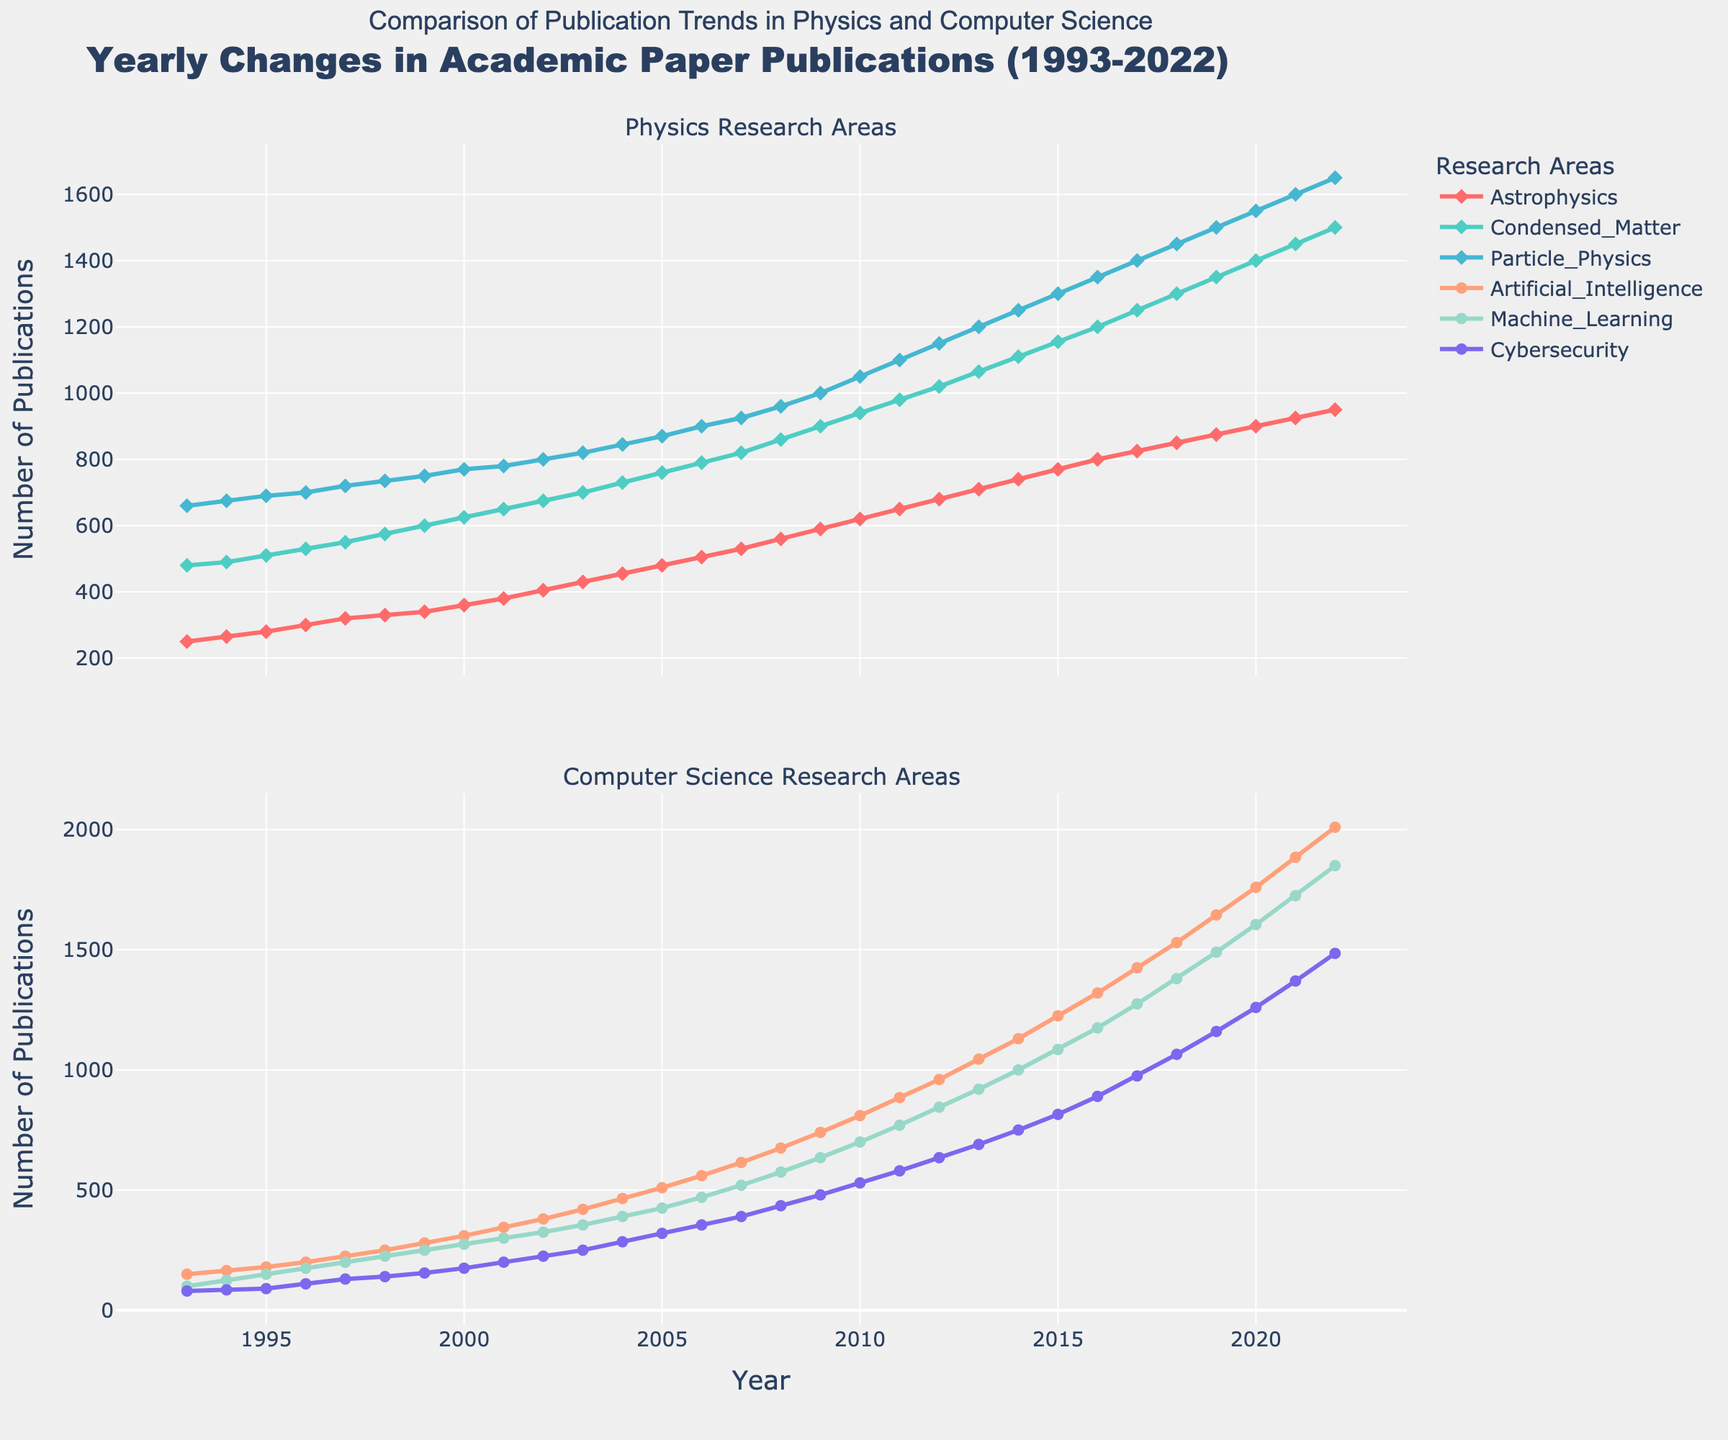What is the title of the plot? The title is located at the top of the figure and provides a summary of what the plot represents. It reads "Yearly Changes in Academic Paper Publications (1993-2022)".
Answer: Yearly Changes in Academic Paper Publications (1993-2022) Which research area in Computer Science had the highest number of publications in 2022? Looking at the bottom subplot for Computer Science research areas in 2022, the line representing Artificial Intelligence sits the highest on the vertical axis.
Answer: Artificial Intelligence What is the overall trend in the number of publications in the Condensed Matter subfield of Physics over the last 30 years? Observing the line corresponding to Condensed Matter in the top subplot, we see a consistent rise from 480 publications in 1993 to 1500 in 2022.
Answer: Increasing trend How many more publications were there in Machine Learning compared to Cybersecurity in 2020? In 2020, Machine Learning had 1605 publications and Cybersecurity had 1260. The difference is 1605 - 1260.
Answer: 345 Which year did Astrophysics surpass 600 publications, and by how much did it increase? Looking at the Astrophysics line in the top subplot, it first surpasses 600 in 2001 (with 620 publications). From 600 publications in 2000 to 620 in 2001, the increase is 20 publications.
Answer: 2001, 20 publications Which Physics research area had the lowest publication count in 1993, and how many publications were there? In 1993, comparing Astrophysics (250), Condensed Matter (480), and Particle Physics (660), Astrophysics had the lowest count of publications.
Answer: Astrophysics, 250 publications By how much did the overall number of publications in the Particle Physics field grow from 1993 to 2022? Particle Physics had 660 publications in 1993 and 1650 in 2022. The growth is 1650 - 660.
Answer: 990 What was the number of publications in Astrophysics in 2010 compared to Artificial Intelligence in the same year? In 2010, Astrophysics had 620 publications, and Artificial Intelligence had 810. Artificial Intelligence had more.
Answer: 810 (Artificial Intelligence) vs. 620 (Astrophysics) How did the publication numbers in Cybersecurity and Condensed Matter converge over time? Initially, Cybersecurity publications (80 in 1993) were much lower than Condensed Matter (480 in 1993). Over the years, both fields saw increases, with Cybersecurity reaching 1485 in 2022 and Condensed Matter reaching 1500. The publication numbers converged closely towards 2022, with respective values being nearly equal.
Answer: Converged closely by 2022 